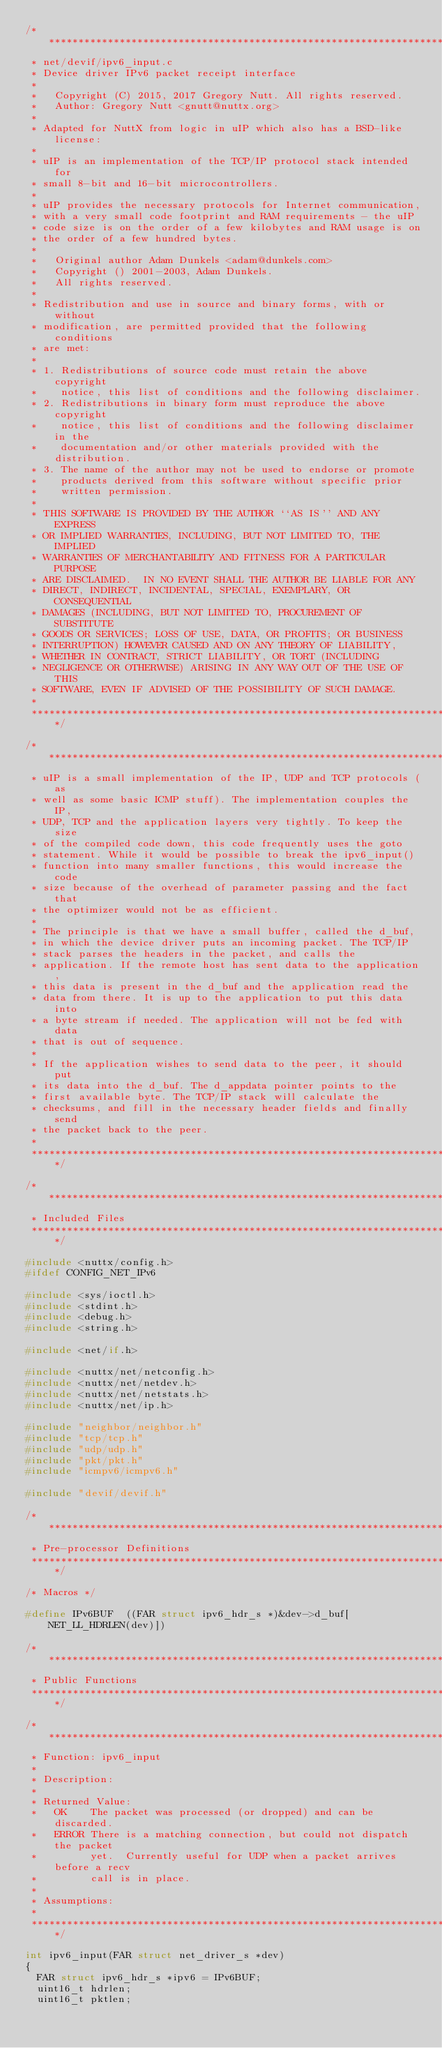<code> <loc_0><loc_0><loc_500><loc_500><_C_>/****************************************************************************
 * net/devif/ipv6_input.c
 * Device driver IPv6 packet receipt interface
 *
 *   Copyright (C) 2015, 2017 Gregory Nutt. All rights reserved.
 *   Author: Gregory Nutt <gnutt@nuttx.org>
 *
 * Adapted for NuttX from logic in uIP which also has a BSD-like license:
 *
 * uIP is an implementation of the TCP/IP protocol stack intended for
 * small 8-bit and 16-bit microcontrollers.
 *
 * uIP provides the necessary protocols for Internet communication,
 * with a very small code footprint and RAM requirements - the uIP
 * code size is on the order of a few kilobytes and RAM usage is on
 * the order of a few hundred bytes.
 *
 *   Original author Adam Dunkels <adam@dunkels.com>
 *   Copyright () 2001-2003, Adam Dunkels.
 *   All rights reserved.
 *
 * Redistribution and use in source and binary forms, with or without
 * modification, are permitted provided that the following conditions
 * are met:
 *
 * 1. Redistributions of source code must retain the above copyright
 *    notice, this list of conditions and the following disclaimer.
 * 2. Redistributions in binary form must reproduce the above copyright
 *    notice, this list of conditions and the following disclaimer in the
 *    documentation and/or other materials provided with the distribution.
 * 3. The name of the author may not be used to endorse or promote
 *    products derived from this software without specific prior
 *    written permission.
 *
 * THIS SOFTWARE IS PROVIDED BY THE AUTHOR ``AS IS'' AND ANY EXPRESS
 * OR IMPLIED WARRANTIES, INCLUDING, BUT NOT LIMITED TO, THE IMPLIED
 * WARRANTIES OF MERCHANTABILITY AND FITNESS FOR A PARTICULAR PURPOSE
 * ARE DISCLAIMED.  IN NO EVENT SHALL THE AUTHOR BE LIABLE FOR ANY
 * DIRECT, INDIRECT, INCIDENTAL, SPECIAL, EXEMPLARY, OR CONSEQUENTIAL
 * DAMAGES (INCLUDING, BUT NOT LIMITED TO, PROCUREMENT OF SUBSTITUTE
 * GOODS OR SERVICES; LOSS OF USE, DATA, OR PROFITS; OR BUSINESS
 * INTERRUPTION) HOWEVER CAUSED AND ON ANY THEORY OF LIABILITY,
 * WHETHER IN CONTRACT, STRICT LIABILITY, OR TORT (INCLUDING
 * NEGLIGENCE OR OTHERWISE) ARISING IN ANY WAY OUT OF THE USE OF THIS
 * SOFTWARE, EVEN IF ADVISED OF THE POSSIBILITY OF SUCH DAMAGE.
 *
 ****************************************************************************/

/****************************************************************************
 * uIP is a small implementation of the IP, UDP and TCP protocols (as
 * well as some basic ICMP stuff). The implementation couples the IP,
 * UDP, TCP and the application layers very tightly. To keep the size
 * of the compiled code down, this code frequently uses the goto
 * statement. While it would be possible to break the ipv6_input()
 * function into many smaller functions, this would increase the code
 * size because of the overhead of parameter passing and the fact that
 * the optimizer would not be as efficient.
 *
 * The principle is that we have a small buffer, called the d_buf,
 * in which the device driver puts an incoming packet. The TCP/IP
 * stack parses the headers in the packet, and calls the
 * application. If the remote host has sent data to the application,
 * this data is present in the d_buf and the application read the
 * data from there. It is up to the application to put this data into
 * a byte stream if needed. The application will not be fed with data
 * that is out of sequence.
 *
 * If the application wishes to send data to the peer, it should put
 * its data into the d_buf. The d_appdata pointer points to the
 * first available byte. The TCP/IP stack will calculate the
 * checksums, and fill in the necessary header fields and finally send
 * the packet back to the peer.
 *
 ****************************************************************************/

/****************************************************************************
 * Included Files
 ****************************************************************************/

#include <nuttx/config.h>
#ifdef CONFIG_NET_IPv6

#include <sys/ioctl.h>
#include <stdint.h>
#include <debug.h>
#include <string.h>

#include <net/if.h>

#include <nuttx/net/netconfig.h>
#include <nuttx/net/netdev.h>
#include <nuttx/net/netstats.h>
#include <nuttx/net/ip.h>

#include "neighbor/neighbor.h"
#include "tcp/tcp.h"
#include "udp/udp.h"
#include "pkt/pkt.h"
#include "icmpv6/icmpv6.h"

#include "devif/devif.h"

/****************************************************************************
 * Pre-processor Definitions
 ****************************************************************************/

/* Macros */

#define IPv6BUF  ((FAR struct ipv6_hdr_s *)&dev->d_buf[NET_LL_HDRLEN(dev)])

/****************************************************************************
 * Public Functions
 ****************************************************************************/

/****************************************************************************
 * Function: ipv6_input
 *
 * Description:
 *
 * Returned Value:
 *   OK    The packet was processed (or dropped) and can be discarded.
 *   ERROR There is a matching connection, but could not dispatch the packet
 *         yet.  Currently useful for UDP when a packet arrives before a recv
 *         call is in place.
 *
 * Assumptions:
 *
 ****************************************************************************/

int ipv6_input(FAR struct net_driver_s *dev)
{
  FAR struct ipv6_hdr_s *ipv6 = IPv6BUF;
  uint16_t hdrlen;
  uint16_t pktlen;
</code> 